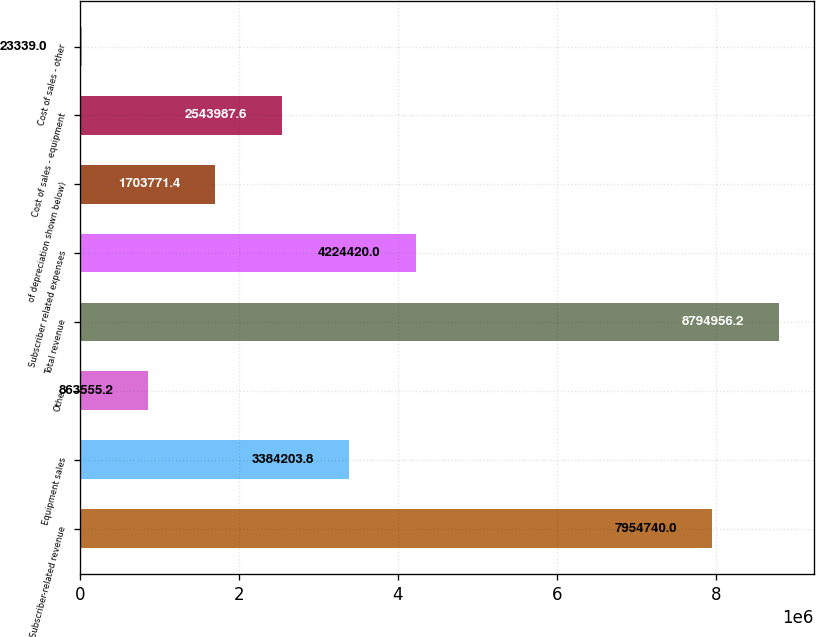Convert chart to OTSL. <chart><loc_0><loc_0><loc_500><loc_500><bar_chart><fcel>Subscriber-related revenue<fcel>Equipment sales<fcel>Other<fcel>Total revenue<fcel>Subscriber related expenses<fcel>of depreciation shown below)<fcel>Cost of sales - equipment<fcel>Cost of sales - other<nl><fcel>7.95474e+06<fcel>3.3842e+06<fcel>863555<fcel>8.79496e+06<fcel>4.22442e+06<fcel>1.70377e+06<fcel>2.54399e+06<fcel>23339<nl></chart> 